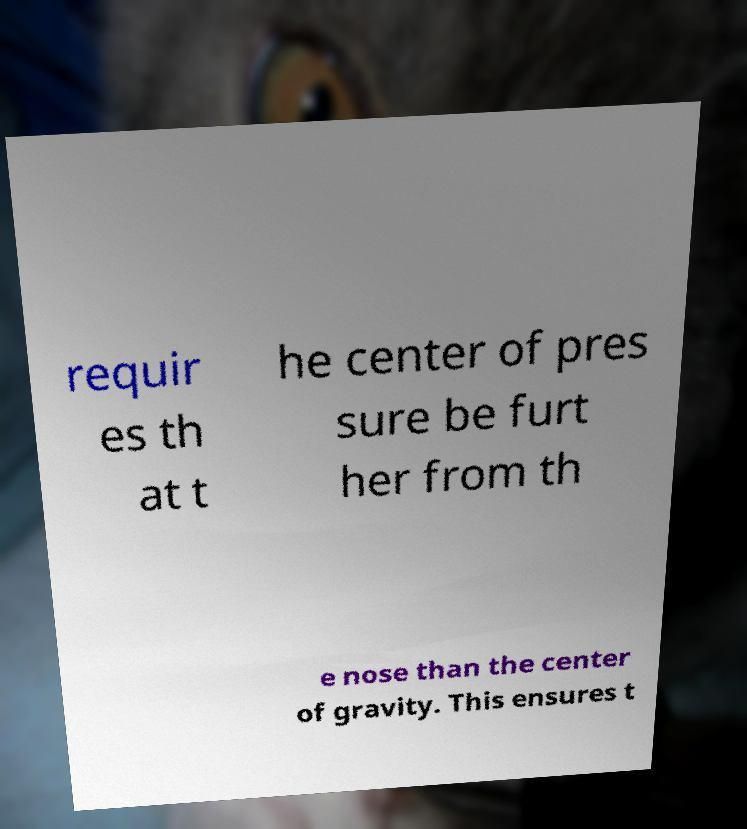Could you extract and type out the text from this image? requir es th at t he center of pres sure be furt her from th e nose than the center of gravity. This ensures t 